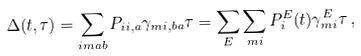<formula> <loc_0><loc_0><loc_500><loc_500>\Delta ( t , \tau ) = \sum _ { i m a b } P _ { i i , a } \gamma _ { m i , b a } \tau = \sum _ { E } \sum _ { m i } P _ { i } ^ { E } ( t ) \gamma _ { m i } ^ { E } \tau \, ,</formula> 